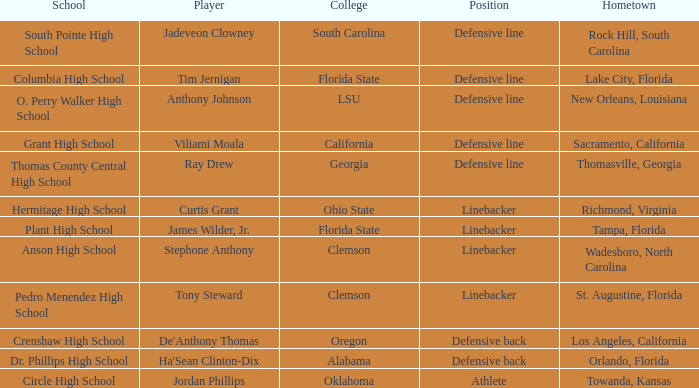Which athlete hails from tampa, florida? James Wilder, Jr. 